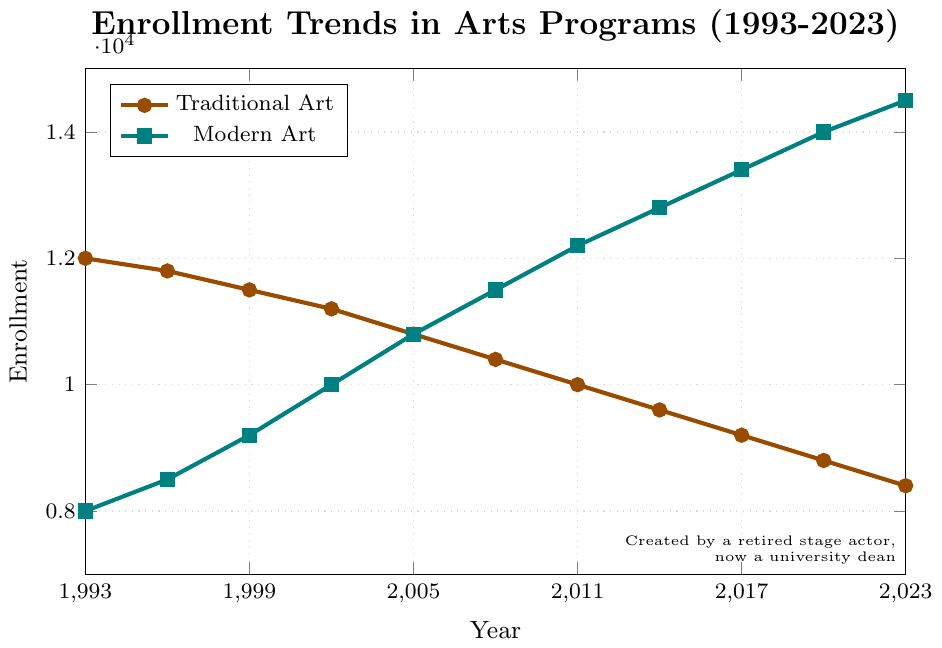Which art discipline had higher enrollment in 1993? In 1993, we look at the enrollment values for traditional and modern art. Traditional Art had 12,000 and Modern Art had 8,000.
Answer: Traditional Art Has the enrollment in traditional art ever been equal to enrollment in modern art? If so, when? Check if both values for Traditional Art and Modern Art are equal at any year. In 2005, both enrollments are 10,800.
Answer: 2005 What is the overall trend in enrollment for traditional art over the 30 years? Observe the line for Traditional Art from 1993 to 2023. The enrollment decreases steadily from 12,000 to 8,400.
Answer: Decreasing By how much did modern art enrollment increase from 1993 to 2023? Subtract the 1993 value from the 2023 value for Modern Art. (14,500 - 8,000) = 6,500.
Answer: 6,500 Which years saw a decreasing trend in modern art enrollment? Look at the Modern Art plot and see if any points have a negative slope. There are no such points; the enrollment always increases.
Answer: None Compare the rate of change in enrollments for traditional and modern art from 2008 to 2011. Calculate the rate of change for both: 
Traditional Art: (10,000 - 10,400)/3 = -400/3
Modern Art: (12,200 - 11,500)/3 = 700/3
Traditional Art's enrollment decreased while Modern Art's enrollment increased.
Answer: Traditional decreased, Modern increased What color represents modern art in the chart? Identify the color used for the line representing Modern Art. It is a blueish-green color.
Answer: Blue-green What was the difference in enrollment between traditional and modern art in 2023? Subtract the 2023 Traditional Art enrollment from the 2023 Modern Art enrollment. (14,500 - 8,400) = 6,100
Answer: 6,100 Which year had the highest enrollment for modern art, and what was the value? Look at the highest point on the Modern Art line. In 2023, enrollment was 14,500.
Answer: 2023, 14,500 What was the average enrollment for traditional art over the entire period? Calculate the average by summing all Traditional Art values and dividing by the number of years:
(12,000 + 11,800 + 11,500 + 11,200 + 10,800 + 10,400 + 10,000 + 9,600 + 9,200 + 8,800 + 8,400)/11 = 10,163.64
Answer: 10,163.64 